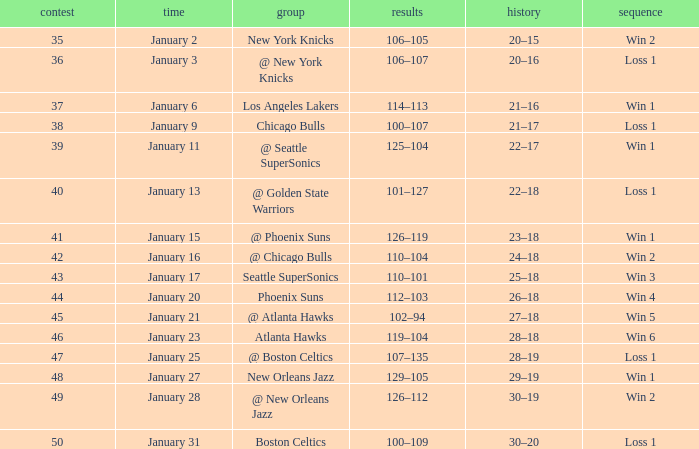What is the Team in Game 38? Chicago Bulls. 